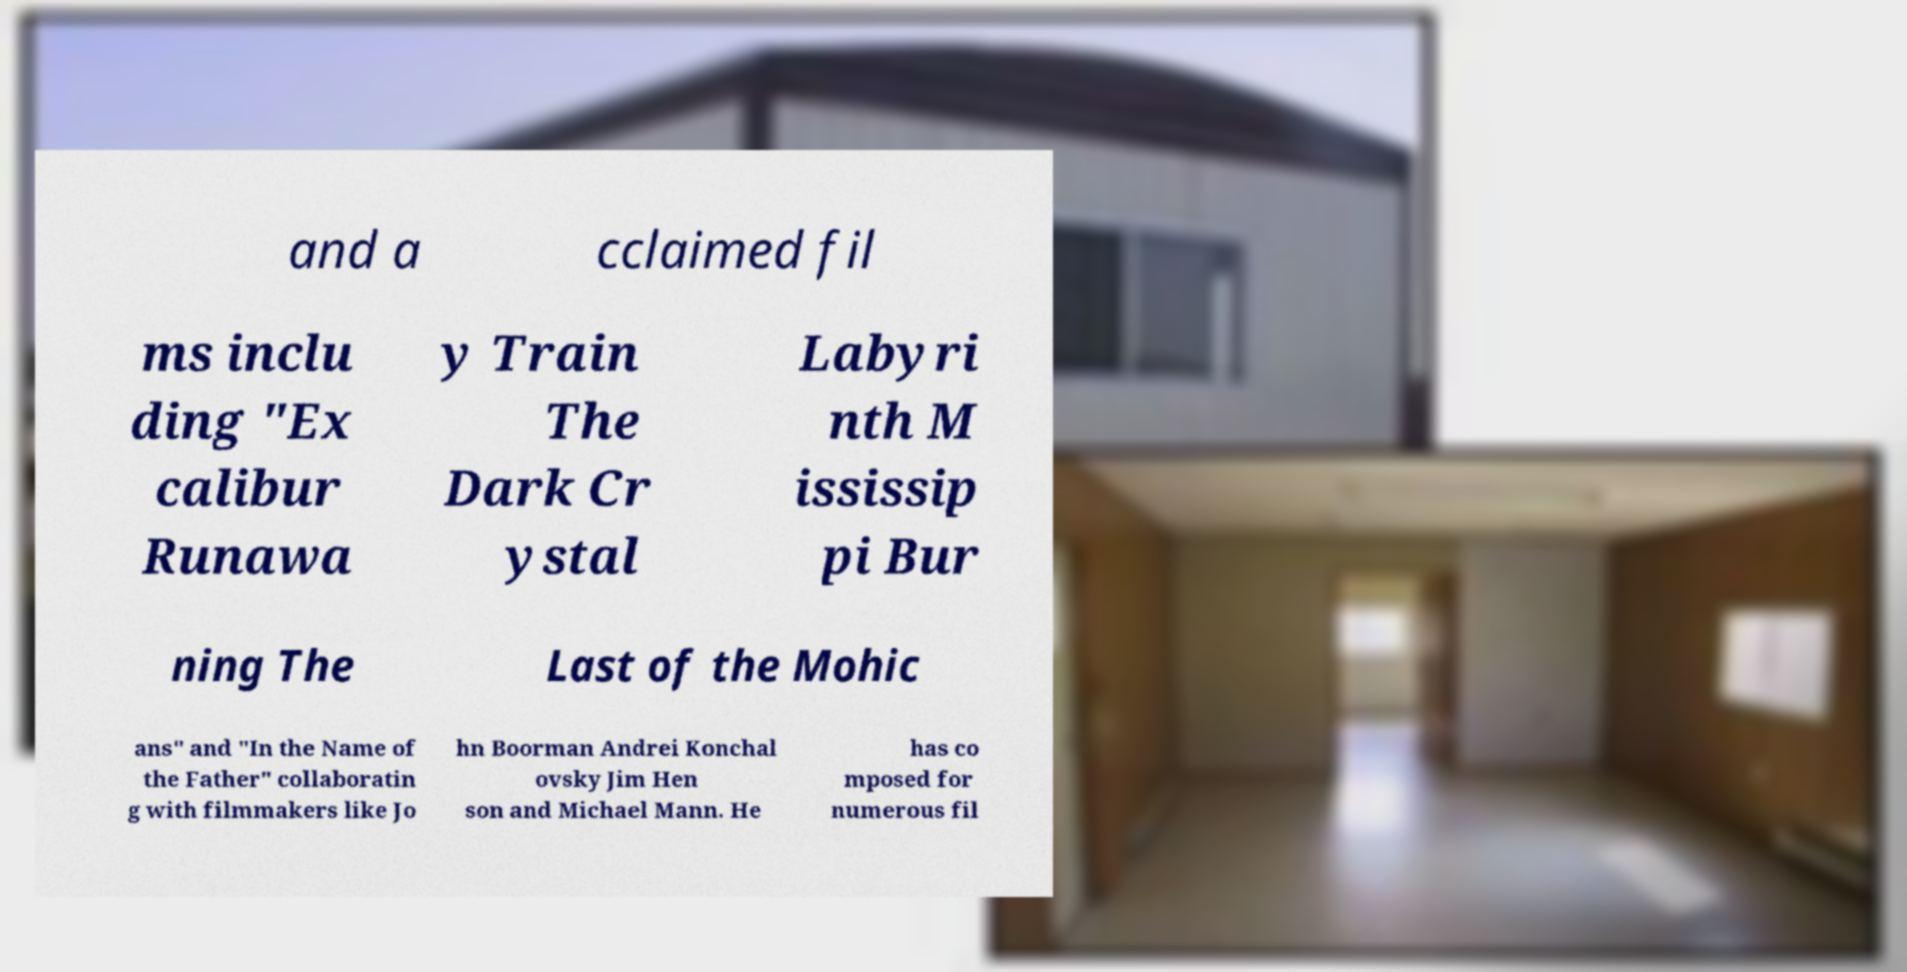What messages or text are displayed in this image? I need them in a readable, typed format. and a cclaimed fil ms inclu ding "Ex calibur Runawa y Train The Dark Cr ystal Labyri nth M ississip pi Bur ning The Last of the Mohic ans" and "In the Name of the Father" collaboratin g with filmmakers like Jo hn Boorman Andrei Konchal ovsky Jim Hen son and Michael Mann. He has co mposed for numerous fil 